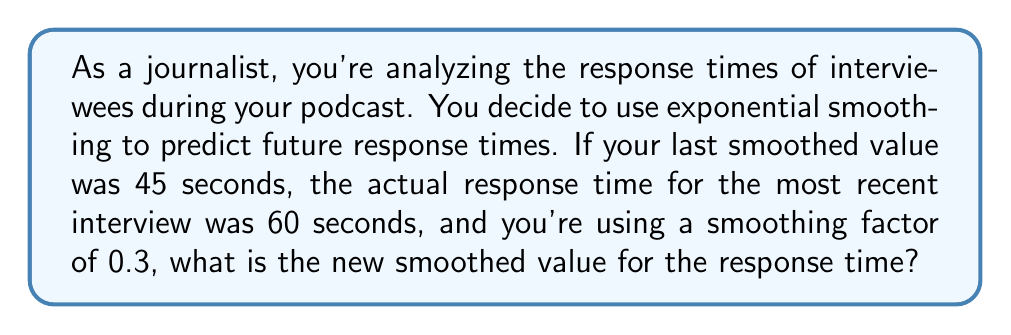Can you solve this math problem? Let's approach this step-by-step using the exponential smoothing formula:

1) The general formula for exponential smoothing is:

   $$S_t = \alpha \cdot x_t + (1 - \alpha) \cdot S_{t-1}$$

   Where:
   $S_t$ is the new smoothed value
   $\alpha$ is the smoothing factor
   $x_t$ is the current observation
   $S_{t-1}$ is the previous smoothed value

2) We are given:
   $\alpha = 0.3$
   $x_t = 60$ seconds (current response time)
   $S_{t-1} = 45$ seconds (previous smoothed value)

3) Let's substitute these values into our formula:

   $$S_t = 0.3 \cdot 60 + (1 - 0.3) \cdot 45$$

4) Simplify:
   $$S_t = 18 + 0.7 \cdot 45$$
   $$S_t = 18 + 31.5$$

5) Calculate the final result:
   $$S_t = 49.5$$

Therefore, the new smoothed value for the response time is 49.5 seconds.
Answer: 49.5 seconds 